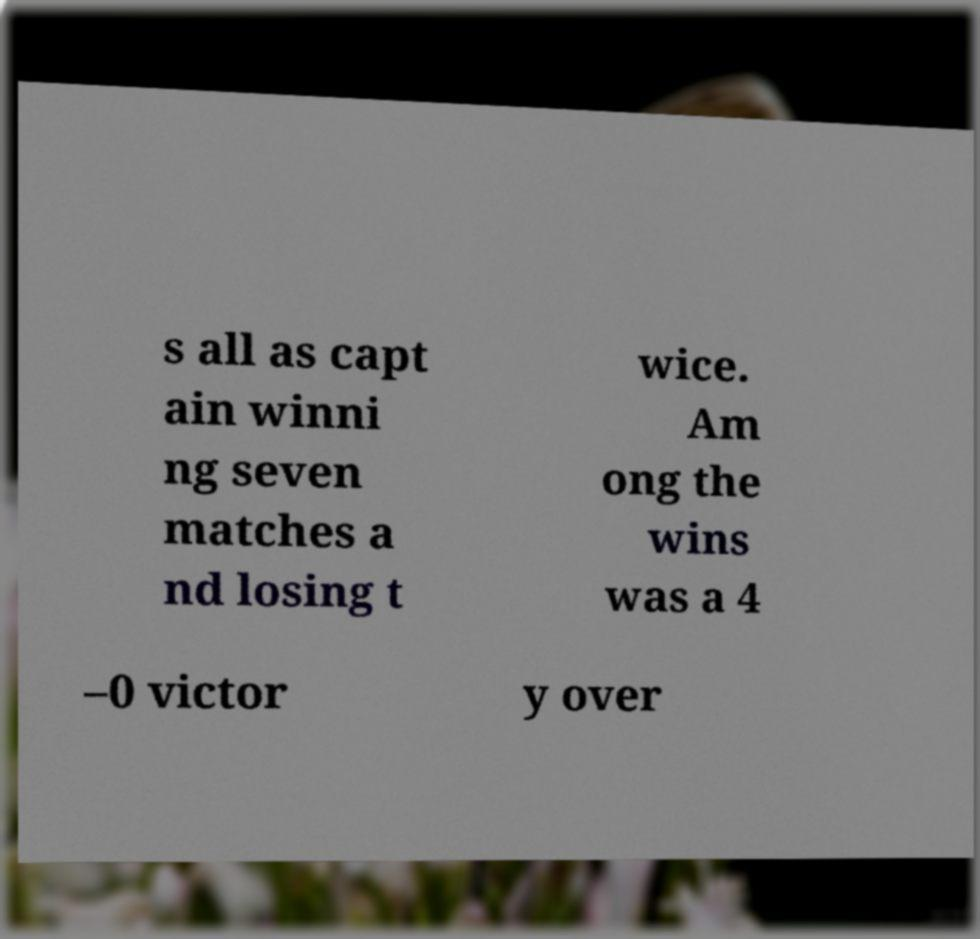Please identify and transcribe the text found in this image. s all as capt ain winni ng seven matches a nd losing t wice. Am ong the wins was a 4 –0 victor y over 